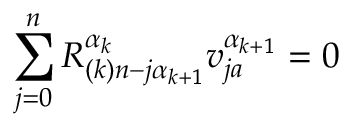<formula> <loc_0><loc_0><loc_500><loc_500>\sum _ { j = 0 } ^ { n } R _ { ( k ) n - j \alpha _ { k + 1 } } ^ { \alpha _ { k } } v _ { j a } ^ { \alpha _ { k + 1 } } = 0</formula> 